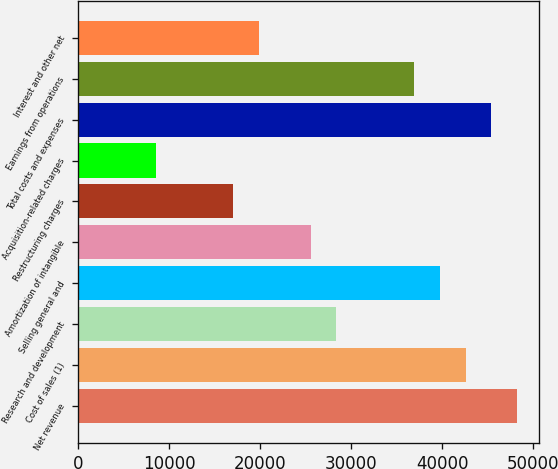<chart> <loc_0><loc_0><loc_500><loc_500><bar_chart><fcel>Net revenue<fcel>Cost of sales (1)<fcel>Research and development<fcel>Selling general and<fcel>Amortization of intangible<fcel>Restructuring charges<fcel>Acquisition-related charges<fcel>Total costs and expenses<fcel>Earnings from operations<fcel>Interest and other net<nl><fcel>48210.3<fcel>42538.5<fcel>28359<fcel>39702.6<fcel>25523.1<fcel>17015.5<fcel>8507.8<fcel>45374.4<fcel>36866.7<fcel>19851.4<nl></chart> 